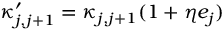Convert formula to latex. <formula><loc_0><loc_0><loc_500><loc_500>\kappa _ { j , j + 1 } ^ { \prime } = \kappa _ { j , j + 1 } ( 1 + \eta e _ { j } )</formula> 